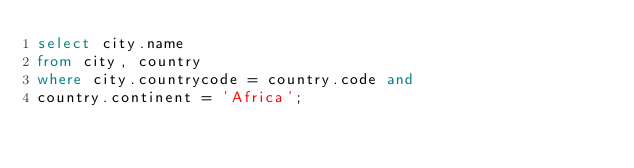Convert code to text. <code><loc_0><loc_0><loc_500><loc_500><_SQL_>select city.name
from city, country
where city.countrycode = country.code and
country.continent = 'Africa';</code> 